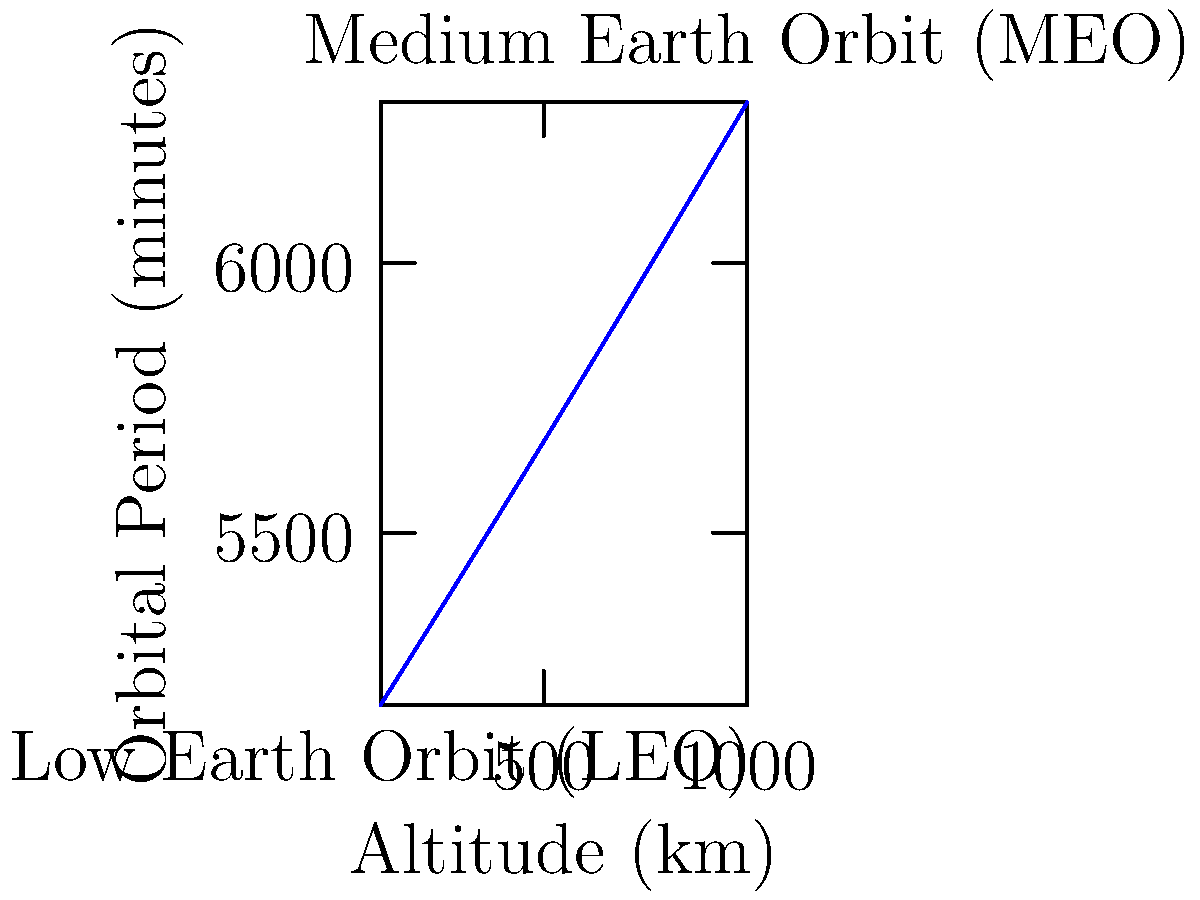As an experienced astronaut, analyze the graph showing the relationship between orbital altitude and period for satellites. If a satellite needs to complete one orbit every 120 minutes, approximately what altitude should it be placed at? How does this relate to common satellite orbits? To solve this problem, we'll follow these steps:

1) The graph shows orbital period on the y-axis and altitude on the x-axis.

2) We need to find the altitude corresponding to a period of 120 minutes.

3) Tracing a horizontal line from 120 minutes on the y-axis until it intersects the curve, then dropping a vertical line to the x-axis gives us the approximate altitude.

4) From the graph, we can see that 120 minutes corresponds to an altitude of about 800 km.

5) This altitude falls within the Low Earth Orbit (LEO) range, which typically extends from about 160 km to 2,000 km above Earth's surface.

6) LEO is commonly used for Earth observation satellites, weather satellites, and some communication satellites, as well as the International Space Station.

7) The relationship shown in the graph is governed by Kepler's Third Law of Planetary Motion, which states that the square of the orbital period of a planet is directly proportional to the cube of the semi-major axis of its orbit.

8) For circular orbits (which most satellites use), the semi-major axis is the radius of the orbit, which is the sum of Earth's radius (approximately 6,371 km) and the satellite's altitude.

9) The mathematical form of this relationship for Earth satellites is:

   $$T = 2\pi\sqrt{\frac{(R_E + h)^3}{\mu}}$$

   Where $T$ is the orbital period, $R_E$ is Earth's radius, $h$ is the orbital altitude, and $\mu$ is Earth's standard gravitational parameter.

10) This explains the curve's shape: as altitude increases, the orbital period increases non-linearly.
Answer: Approximately 800 km, within Low Earth Orbit (LEO) 